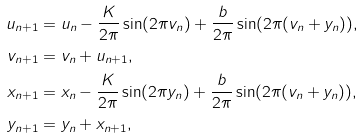<formula> <loc_0><loc_0><loc_500><loc_500>u _ { n + 1 } & = u _ { n } - \frac { K } { 2 \pi } \sin ( 2 \pi v _ { n } ) + \frac { b } { 2 \pi } \sin ( 2 \pi ( v _ { n } + y _ { n } ) ) , \\ v _ { n + 1 } & = v _ { n } + u _ { n + 1 } , \\ x _ { n + 1 } & = x _ { n } - \frac { K } { 2 \pi } \sin ( 2 \pi y _ { n } ) + \frac { b } { 2 \pi } \sin ( 2 \pi ( v _ { n } + y _ { n } ) ) , \\ y _ { n + 1 } & = y _ { n } + x _ { n + 1 } ,</formula> 